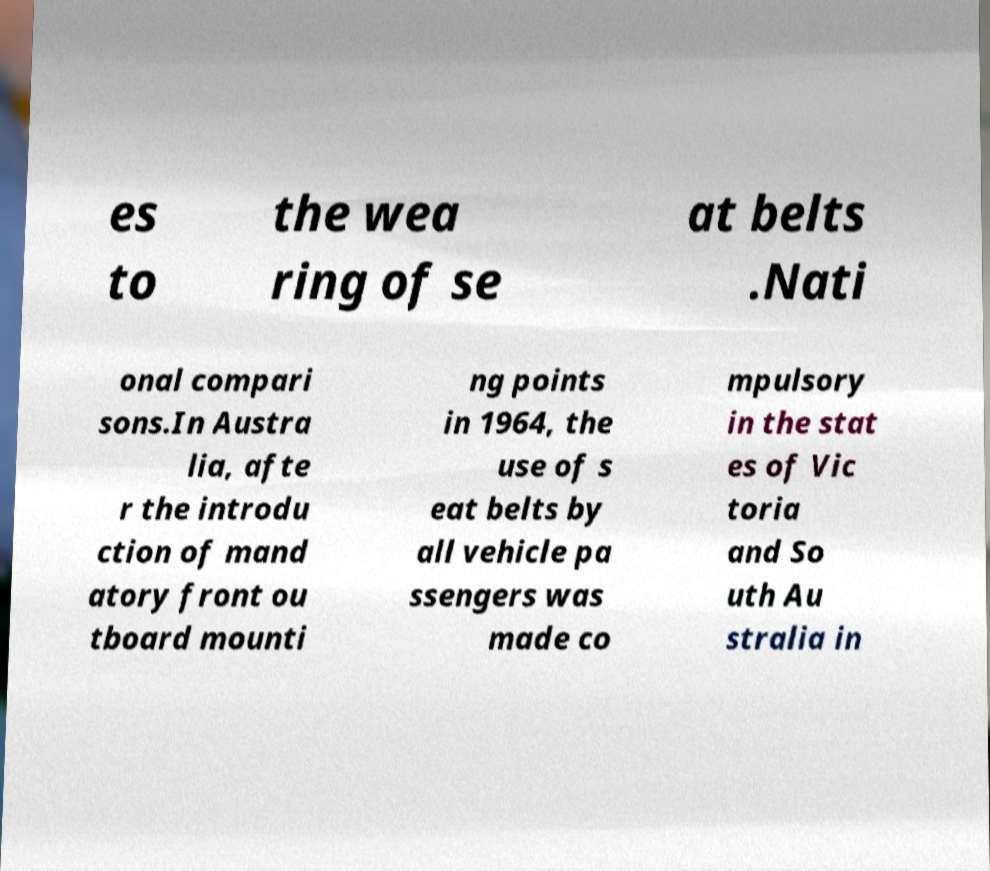Please read and relay the text visible in this image. What does it say? es to the wea ring of se at belts .Nati onal compari sons.In Austra lia, afte r the introdu ction of mand atory front ou tboard mounti ng points in 1964, the use of s eat belts by all vehicle pa ssengers was made co mpulsory in the stat es of Vic toria and So uth Au stralia in 